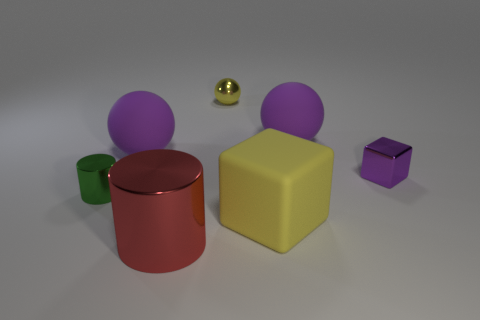Could you guess the relative sizes of these objects? Based on the perspective in the image, the purple spheres seem to be the largest objects present, followed by the yellow cuboid, red cylinder, and purple cube. The green cylinder and the tiny metallic ball appear to be the smallest. 